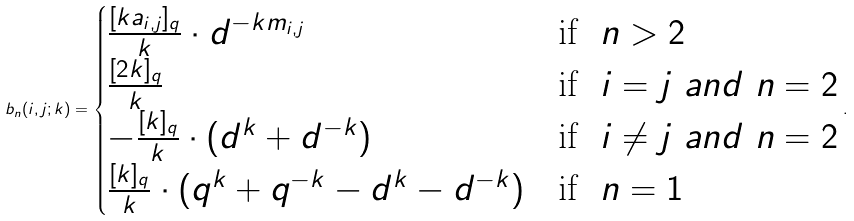<formula> <loc_0><loc_0><loc_500><loc_500>b _ { n } ( i , j ; k ) = \begin{cases} \frac { [ k a _ { i , j } ] _ { q } } { k } \cdot d ^ { - k m _ { i , j } } & \text {if} \ \ n > 2 \\ \frac { [ 2 k ] _ { q } } { k } & \text {if} \ \ i = j \ a n d \ n = 2 \\ - \frac { [ k ] _ { q } } { k } \cdot ( d ^ { k } + d ^ { - k } ) & \text {if} \ \ i \ne j \ a n d \ n = 2 \\ \frac { [ k ] _ { q } } { k } \cdot ( q ^ { k } + q ^ { - k } - d ^ { k } - d ^ { - k } ) & \text {if} \ \ n = 1 \end{cases} .</formula> 